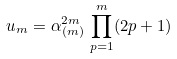Convert formula to latex. <formula><loc_0><loc_0><loc_500><loc_500>u _ { m } = \alpha _ { ( m ) } ^ { 2 m } \, \prod _ { p = 1 } ^ { m } ( 2 p + 1 )</formula> 